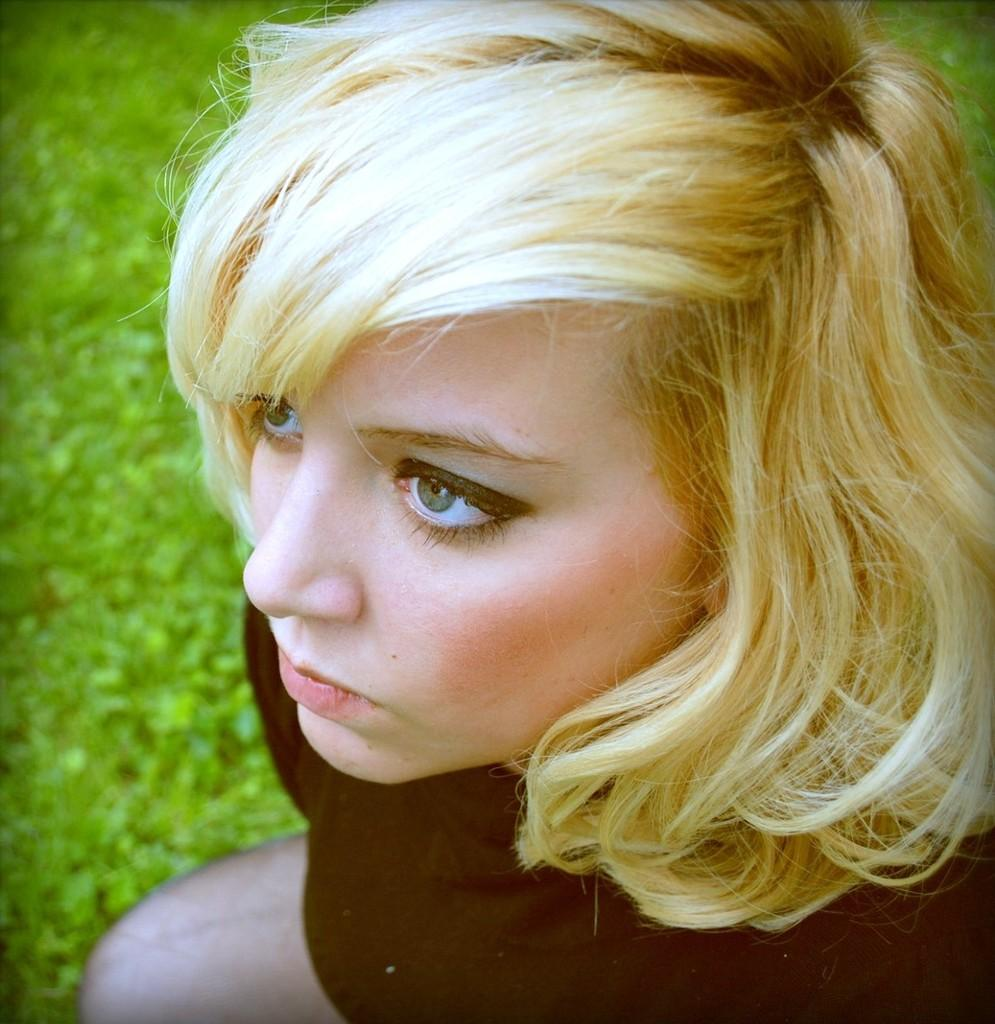Who is present in the image? There is a woman in the image. What can be seen in the background of the image? The background of the image is green. What type of impulse can be seen affecting the woman in the image? There is no impulse affecting the woman in the image; she appears to be standing still. 